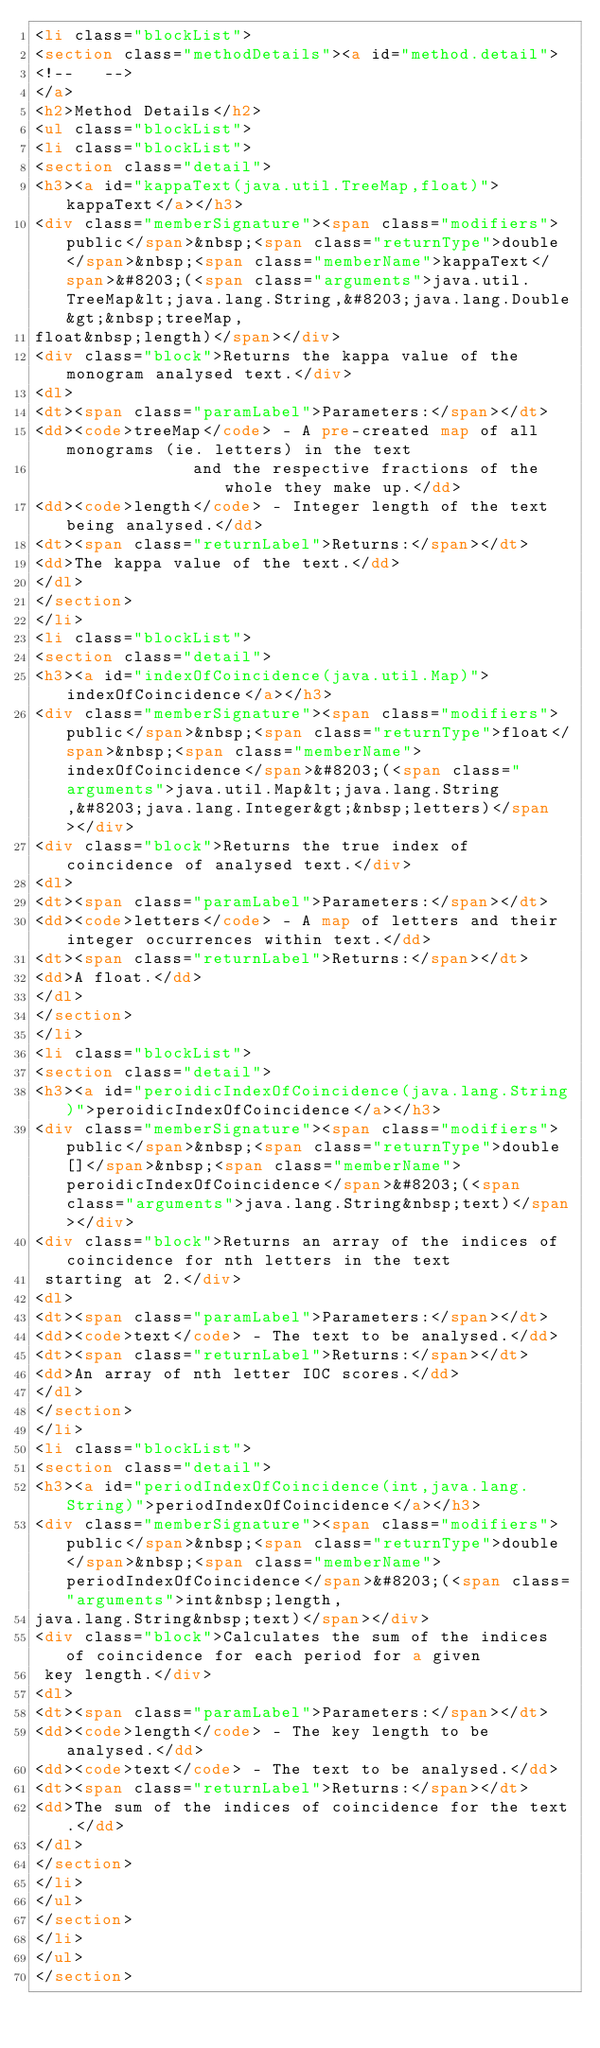Convert code to text. <code><loc_0><loc_0><loc_500><loc_500><_HTML_><li class="blockList">
<section class="methodDetails"><a id="method.detail">
<!--   -->
</a>
<h2>Method Details</h2>
<ul class="blockList">
<li class="blockList">
<section class="detail">
<h3><a id="kappaText(java.util.TreeMap,float)">kappaText</a></h3>
<div class="memberSignature"><span class="modifiers">public</span>&nbsp;<span class="returnType">double</span>&nbsp;<span class="memberName">kappaText</span>&#8203;(<span class="arguments">java.util.TreeMap&lt;java.lang.String,&#8203;java.lang.Double&gt;&nbsp;treeMap,
float&nbsp;length)</span></div>
<div class="block">Returns the kappa value of the monogram analysed text.</div>
<dl>
<dt><span class="paramLabel">Parameters:</span></dt>
<dd><code>treeMap</code> - A pre-created map of all monograms (ie. letters) in the text
                and the respective fractions of the whole they make up.</dd>
<dd><code>length</code> - Integer length of the text being analysed.</dd>
<dt><span class="returnLabel">Returns:</span></dt>
<dd>The kappa value of the text.</dd>
</dl>
</section>
</li>
<li class="blockList">
<section class="detail">
<h3><a id="indexOfCoincidence(java.util.Map)">indexOfCoincidence</a></h3>
<div class="memberSignature"><span class="modifiers">public</span>&nbsp;<span class="returnType">float</span>&nbsp;<span class="memberName">indexOfCoincidence</span>&#8203;(<span class="arguments">java.util.Map&lt;java.lang.String,&#8203;java.lang.Integer&gt;&nbsp;letters)</span></div>
<div class="block">Returns the true index of coincidence of analysed text.</div>
<dl>
<dt><span class="paramLabel">Parameters:</span></dt>
<dd><code>letters</code> - A map of letters and their integer occurrences within text.</dd>
<dt><span class="returnLabel">Returns:</span></dt>
<dd>A float.</dd>
</dl>
</section>
</li>
<li class="blockList">
<section class="detail">
<h3><a id="peroidicIndexOfCoincidence(java.lang.String)">peroidicIndexOfCoincidence</a></h3>
<div class="memberSignature"><span class="modifiers">public</span>&nbsp;<span class="returnType">double[]</span>&nbsp;<span class="memberName">peroidicIndexOfCoincidence</span>&#8203;(<span class="arguments">java.lang.String&nbsp;text)</span></div>
<div class="block">Returns an array of the indices of coincidence for nth letters in the text
 starting at 2.</div>
<dl>
<dt><span class="paramLabel">Parameters:</span></dt>
<dd><code>text</code> - The text to be analysed.</dd>
<dt><span class="returnLabel">Returns:</span></dt>
<dd>An array of nth letter IOC scores.</dd>
</dl>
</section>
</li>
<li class="blockList">
<section class="detail">
<h3><a id="periodIndexOfCoincidence(int,java.lang.String)">periodIndexOfCoincidence</a></h3>
<div class="memberSignature"><span class="modifiers">public</span>&nbsp;<span class="returnType">double</span>&nbsp;<span class="memberName">periodIndexOfCoincidence</span>&#8203;(<span class="arguments">int&nbsp;length,
java.lang.String&nbsp;text)</span></div>
<div class="block">Calculates the sum of the indices of coincidence for each period for a given
 key length.</div>
<dl>
<dt><span class="paramLabel">Parameters:</span></dt>
<dd><code>length</code> - The key length to be analysed.</dd>
<dd><code>text</code> - The text to be analysed.</dd>
<dt><span class="returnLabel">Returns:</span></dt>
<dd>The sum of the indices of coincidence for the text.</dd>
</dl>
</section>
</li>
</ul>
</section>
</li>
</ul>
</section></code> 